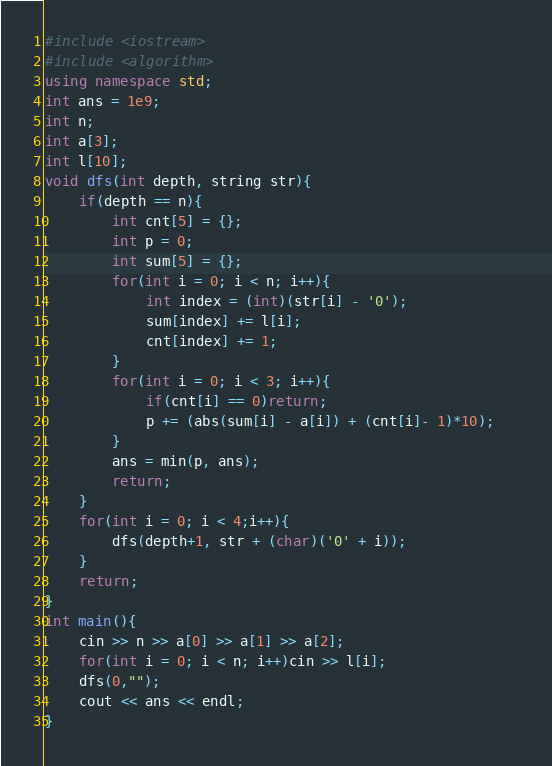<code> <loc_0><loc_0><loc_500><loc_500><_C++_>#include <iostream>
#include <algorithm>
using namespace std;
int ans = 1e9;
int n;
int a[3];
int l[10];
void dfs(int depth, string str){
    if(depth == n){
        int cnt[5] = {};
        int p = 0;
        int sum[5] = {};
        for(int i = 0; i < n; i++){
            int index = (int)(str[i] - '0');
            sum[index] += l[i];
            cnt[index] += 1;
        }
        for(int i = 0; i < 3; i++){
            if(cnt[i] == 0)return;
            p += (abs(sum[i] - a[i]) + (cnt[i]- 1)*10);   
        }
        ans = min(p, ans);
        return;
    }
    for(int i = 0; i < 4;i++){
        dfs(depth+1, str + (char)('0' + i));
    }
    return;
}
int main(){
    cin >> n >> a[0] >> a[1] >> a[2];
    for(int i = 0; i < n; i++)cin >> l[i];
    dfs(0,"");
    cout << ans << endl;
}</code> 